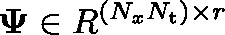Convert formula to latex. <formula><loc_0><loc_0><loc_500><loc_500>\Psi \in \mathbb { R } ^ { ( N _ { x } N _ { t } ) \times r }</formula> 